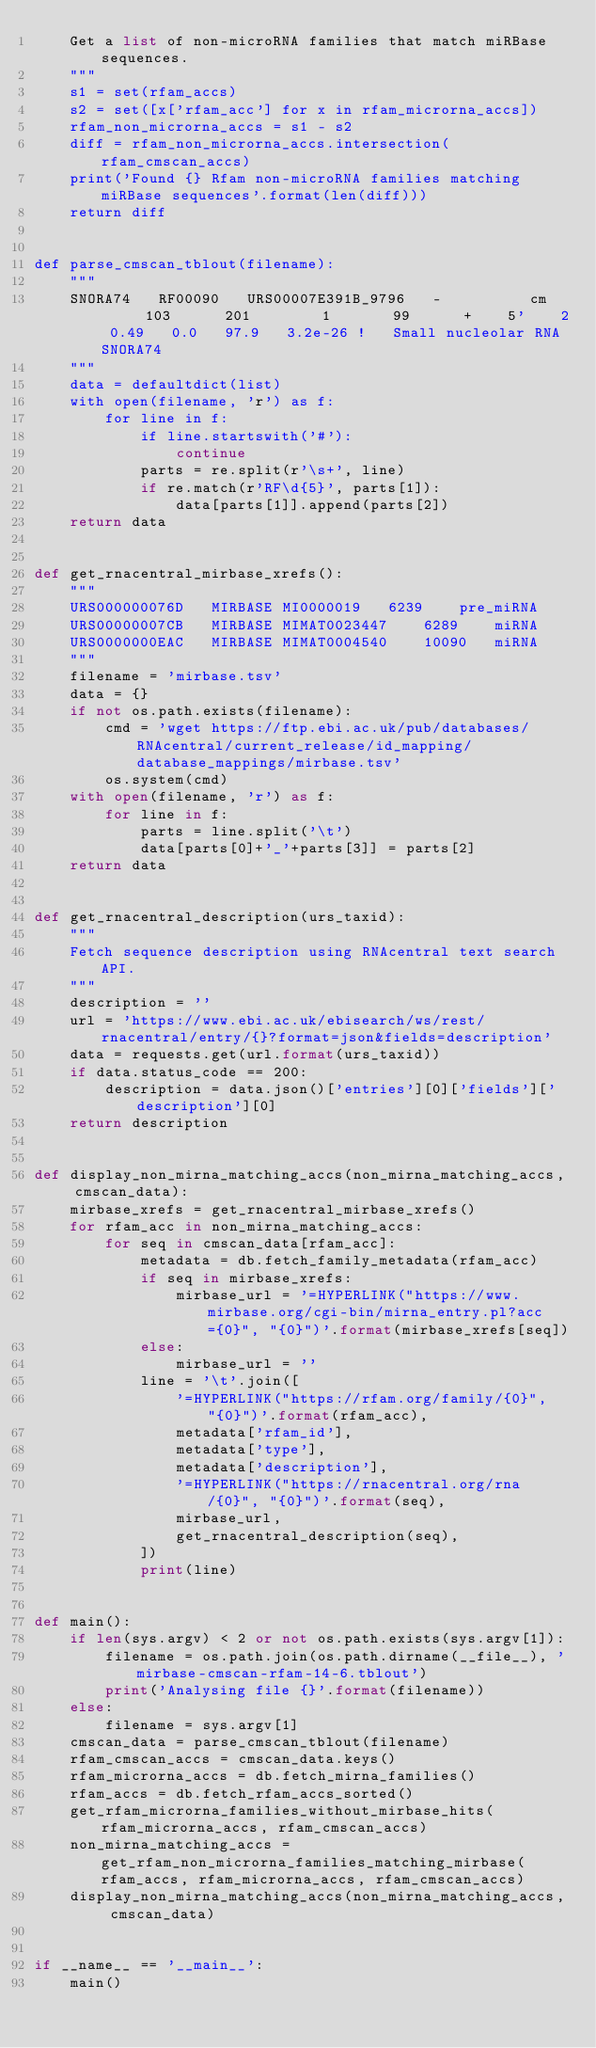Convert code to text. <code><loc_0><loc_0><loc_500><loc_500><_Python_>    Get a list of non-microRNA families that match miRBase sequences.
    """
    s1 = set(rfam_accs)
    s2 = set([x['rfam_acc'] for x in rfam_microrna_accs])
    rfam_non_microrna_accs = s1 - s2
    diff = rfam_non_microrna_accs.intersection(rfam_cmscan_accs)
    print('Found {} Rfam non-microRNA families matching miRBase sequences'.format(len(diff)))
    return diff


def parse_cmscan_tblout(filename):
    """
    SNORA74   RF00090   URS00007E391B_9796   -          cm      103      201        1       99      +    5'    2 0.49   0.0   97.9   3.2e-26 !   Small nucleolar RNA SNORA74
    """
    data = defaultdict(list)
    with open(filename, 'r') as f:
        for line in f:
            if line.startswith('#'):
                continue
            parts = re.split(r'\s+', line)
            if re.match(r'RF\d{5}', parts[1]):
                data[parts[1]].append(parts[2])
    return data


def get_rnacentral_mirbase_xrefs():
    """
    URS000000076D	MIRBASE	MI0000019	6239	pre_miRNA
    URS00000007CB	MIRBASE	MIMAT0023447	6289	miRNA
    URS0000000EAC	MIRBASE	MIMAT0004540	10090	miRNA
    """
    filename = 'mirbase.tsv'
    data = {}
    if not os.path.exists(filename):
        cmd = 'wget https://ftp.ebi.ac.uk/pub/databases/RNAcentral/current_release/id_mapping/database_mappings/mirbase.tsv'
        os.system(cmd)
    with open(filename, 'r') as f:
        for line in f:
            parts = line.split('\t')
            data[parts[0]+'_'+parts[3]] = parts[2]
    return data


def get_rnacentral_description(urs_taxid):
    """
    Fetch sequence description using RNAcentral text search API.
    """
    description = ''
    url = 'https://www.ebi.ac.uk/ebisearch/ws/rest/rnacentral/entry/{}?format=json&fields=description'
    data = requests.get(url.format(urs_taxid))
    if data.status_code == 200:
        description = data.json()['entries'][0]['fields']['description'][0]
    return description


def display_non_mirna_matching_accs(non_mirna_matching_accs, cmscan_data):
    mirbase_xrefs = get_rnacentral_mirbase_xrefs()
    for rfam_acc in non_mirna_matching_accs:
        for seq in cmscan_data[rfam_acc]:
            metadata = db.fetch_family_metadata(rfam_acc)
            if seq in mirbase_xrefs:
                mirbase_url = '=HYPERLINK("https://www.mirbase.org/cgi-bin/mirna_entry.pl?acc={0}", "{0}")'.format(mirbase_xrefs[seq])
            else:
                mirbase_url = ''
            line = '\t'.join([
                '=HYPERLINK("https://rfam.org/family/{0}", "{0}")'.format(rfam_acc),
                metadata['rfam_id'],
                metadata['type'],
                metadata['description'],
                '=HYPERLINK("https://rnacentral.org/rna/{0}", "{0}")'.format(seq),
                mirbase_url,
                get_rnacentral_description(seq),
            ])
            print(line)


def main():
    if len(sys.argv) < 2 or not os.path.exists(sys.argv[1]):
        filename = os.path.join(os.path.dirname(__file__), 'mirbase-cmscan-rfam-14-6.tblout')
        print('Analysing file {}'.format(filename))
    else:
        filename = sys.argv[1]
    cmscan_data = parse_cmscan_tblout(filename)
    rfam_cmscan_accs = cmscan_data.keys()
    rfam_microrna_accs = db.fetch_mirna_families()
    rfam_accs = db.fetch_rfam_accs_sorted()
    get_rfam_microrna_families_without_mirbase_hits(rfam_microrna_accs, rfam_cmscan_accs)
    non_mirna_matching_accs = get_rfam_non_microrna_families_matching_mirbase(rfam_accs, rfam_microrna_accs, rfam_cmscan_accs)
    display_non_mirna_matching_accs(non_mirna_matching_accs, cmscan_data)


if __name__ == '__main__':
    main()
</code> 